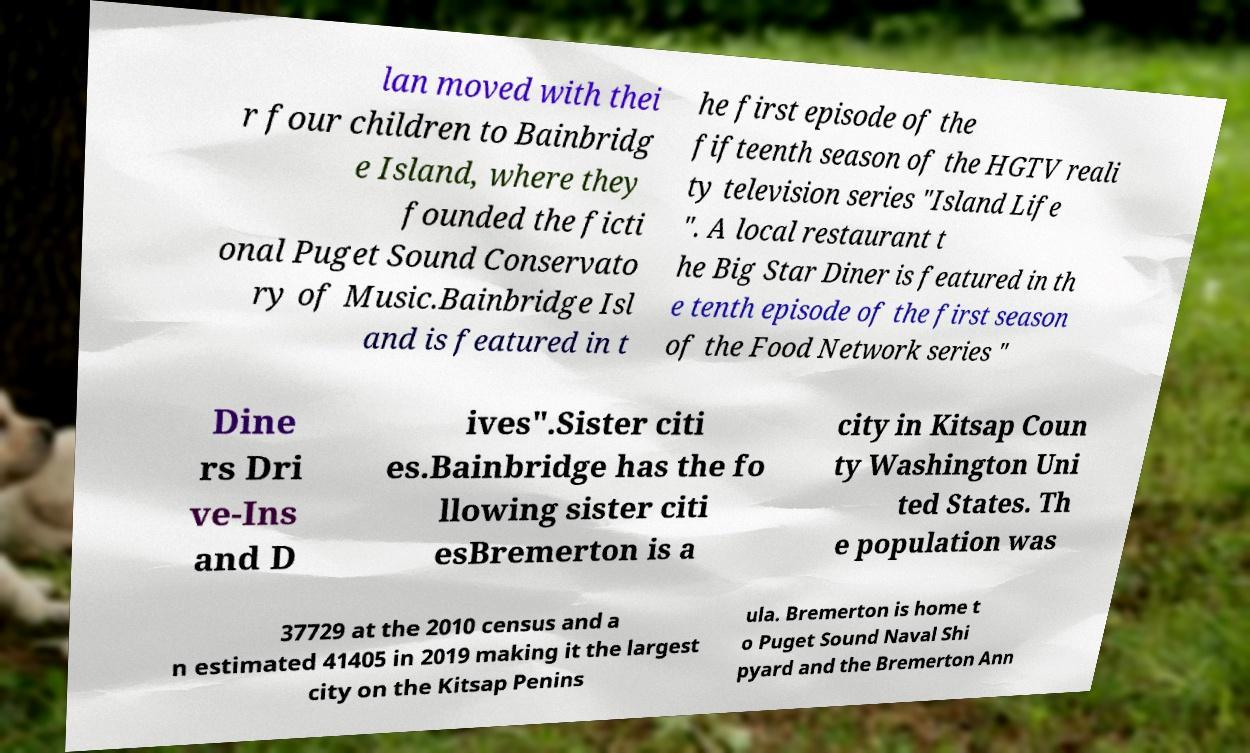Can you accurately transcribe the text from the provided image for me? lan moved with thei r four children to Bainbridg e Island, where they founded the ficti onal Puget Sound Conservato ry of Music.Bainbridge Isl and is featured in t he first episode of the fifteenth season of the HGTV reali ty television series "Island Life ". A local restaurant t he Big Star Diner is featured in th e tenth episode of the first season of the Food Network series " Dine rs Dri ve-Ins and D ives".Sister citi es.Bainbridge has the fo llowing sister citi esBremerton is a city in Kitsap Coun ty Washington Uni ted States. Th e population was 37729 at the 2010 census and a n estimated 41405 in 2019 making it the largest city on the Kitsap Penins ula. Bremerton is home t o Puget Sound Naval Shi pyard and the Bremerton Ann 